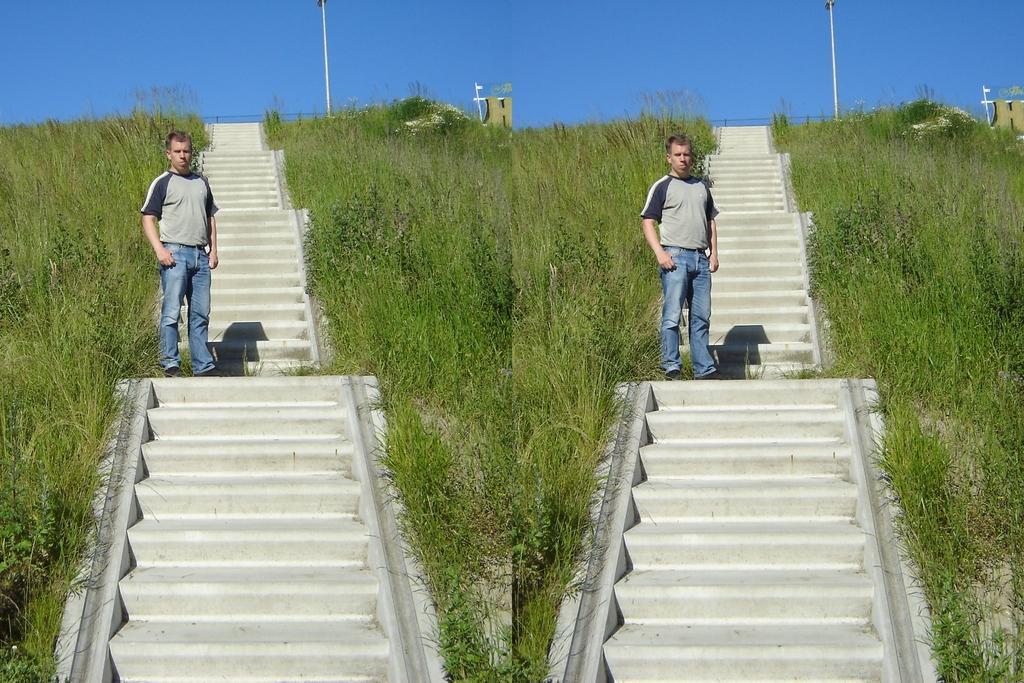Describe this image in one or two sentences. The images is collage with two pictures,both of them are similar picture,a man is standing in between the steps,in the background there is a pole and hut, on the either side of the person there is grass. 